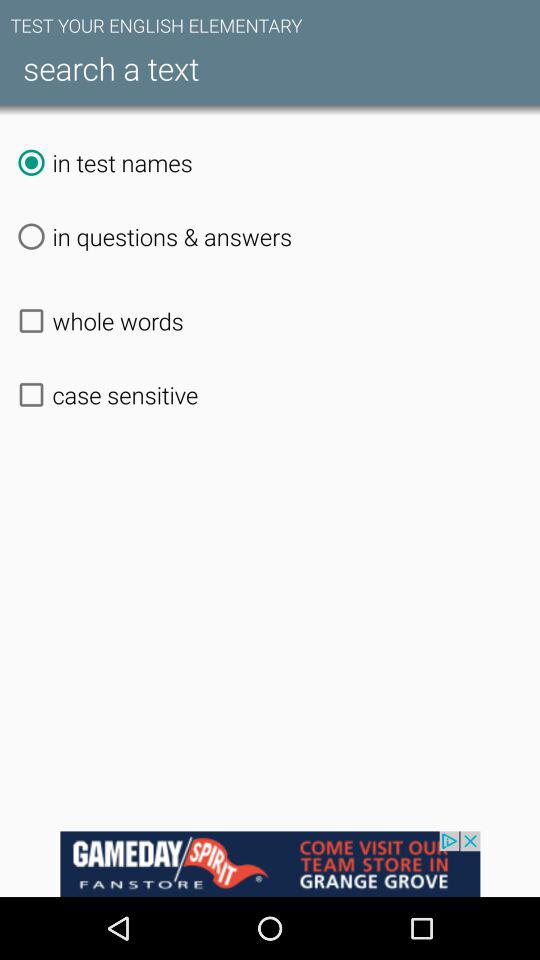What is the status of "whole words"? The status is "off". 